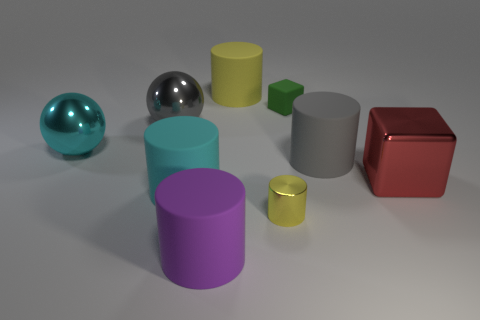There is a large thing that is the same color as the small metallic cylinder; what is its material?
Your answer should be very brief. Rubber. How many matte things are the same color as the tiny metal cylinder?
Keep it short and to the point. 1. There is a small object that is made of the same material as the big cyan sphere; what color is it?
Offer a terse response. Yellow. Are there any gray shiny balls that have the same size as the purple object?
Your answer should be compact. Yes. Is the number of big things that are behind the cyan metal thing greater than the number of big gray matte cylinders that are behind the tiny matte cube?
Provide a short and direct response. Yes. Is the material of the yellow cylinder that is behind the shiny cube the same as the gray thing that is behind the large gray cylinder?
Offer a very short reply. No. What is the shape of the green matte object that is the same size as the shiny cylinder?
Provide a succinct answer. Cube. Are there any large purple matte things that have the same shape as the small metallic thing?
Ensure brevity in your answer.  Yes. There is a rubber cylinder that is to the right of the yellow metallic object; is its color the same as the large shiny thing that is behind the big cyan ball?
Offer a terse response. Yes. There is a large yellow cylinder; are there any cylinders right of it?
Provide a short and direct response. Yes. 